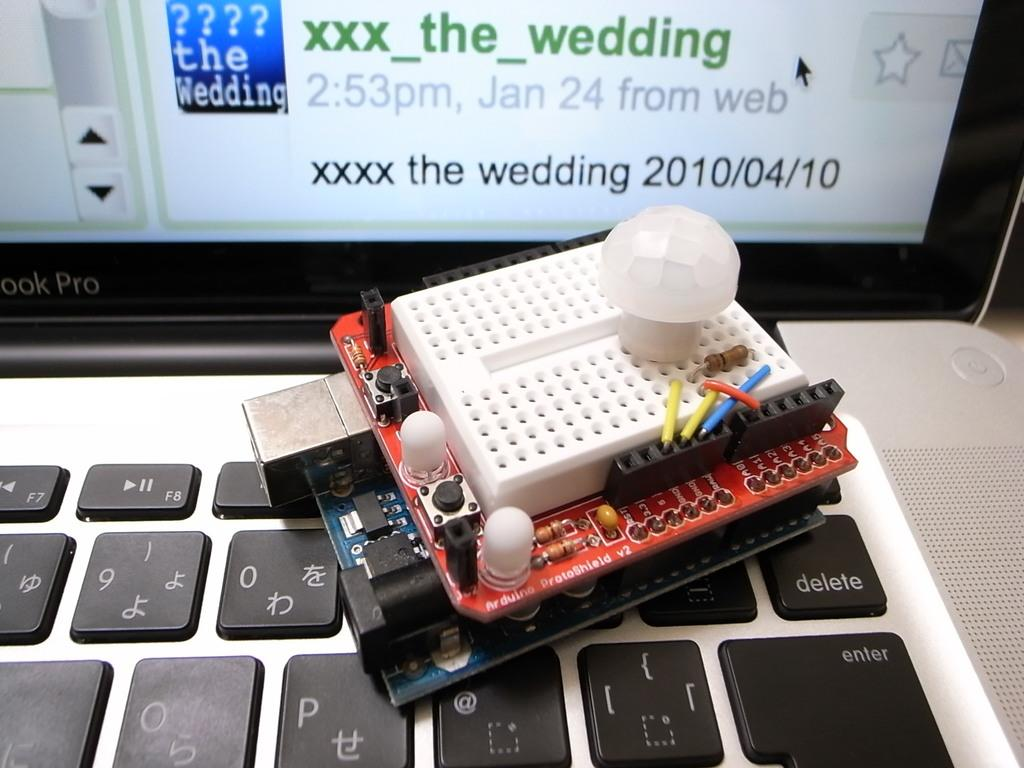<image>
Present a compact description of the photo's key features. A computer screen displaying the date of the wedding, which is 2010/04/10. 